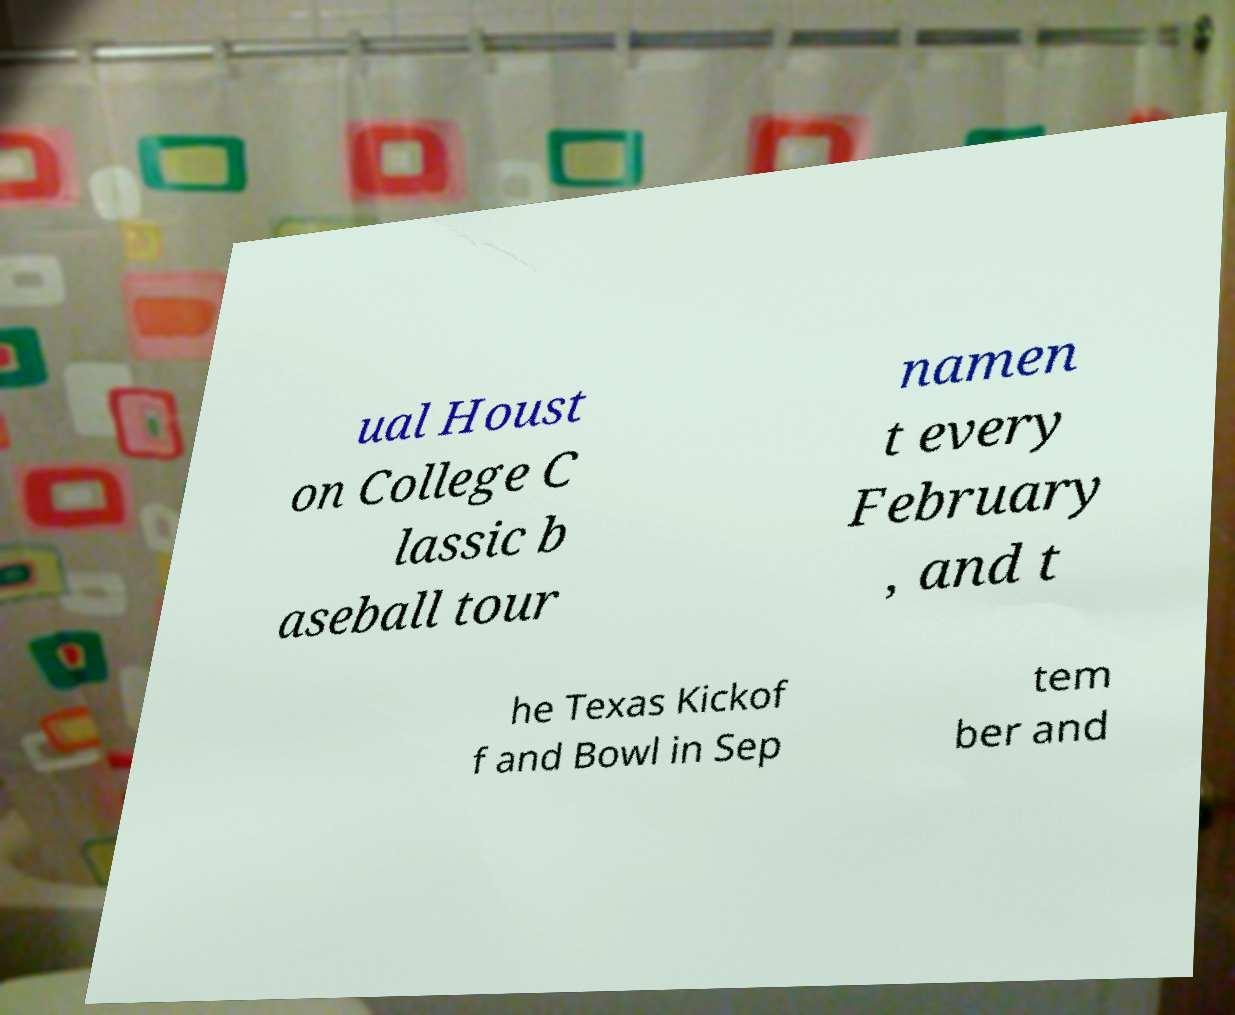Can you accurately transcribe the text from the provided image for me? ual Houst on College C lassic b aseball tour namen t every February , and t he Texas Kickof f and Bowl in Sep tem ber and 